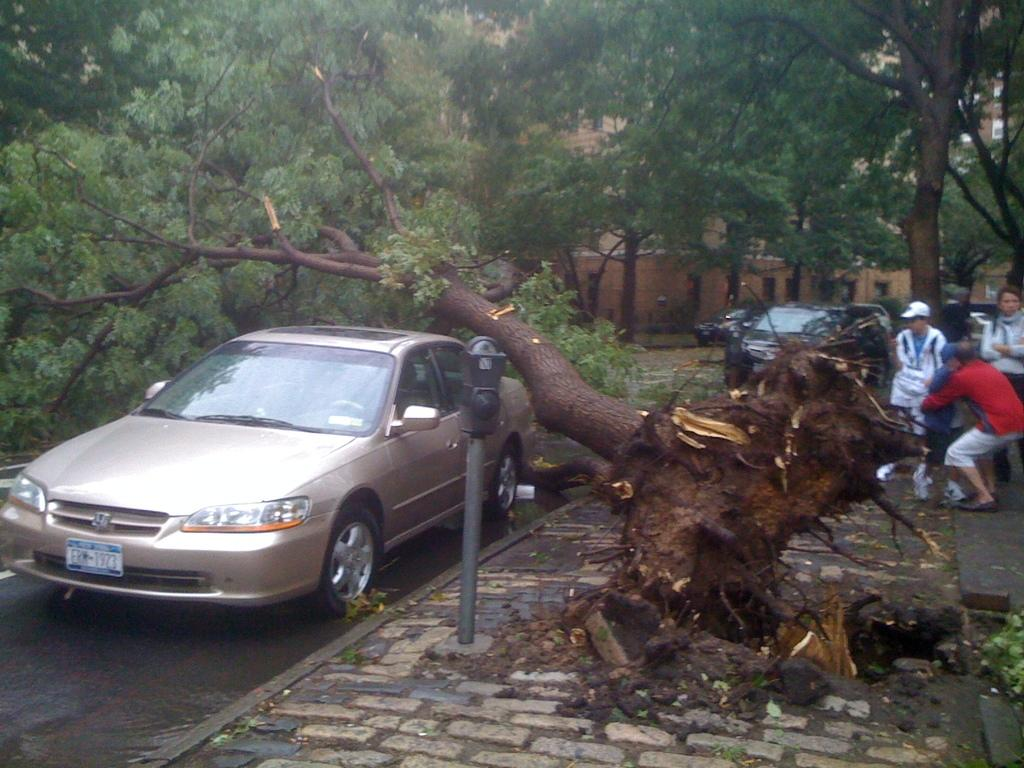What is the main subject of the image? The main subject of the image is a car on the road. What else can be seen in the image besides the car? There is an uprooted tree in the image, as well as people standing on the right side. What is visible in the background of the image? There are trees visible in the background of the image. Is there a boat involved in the battle depicted in the image? There is no boat or battle present in the image; it features a car on the road, an uprooted tree, and people standing on the right side. 